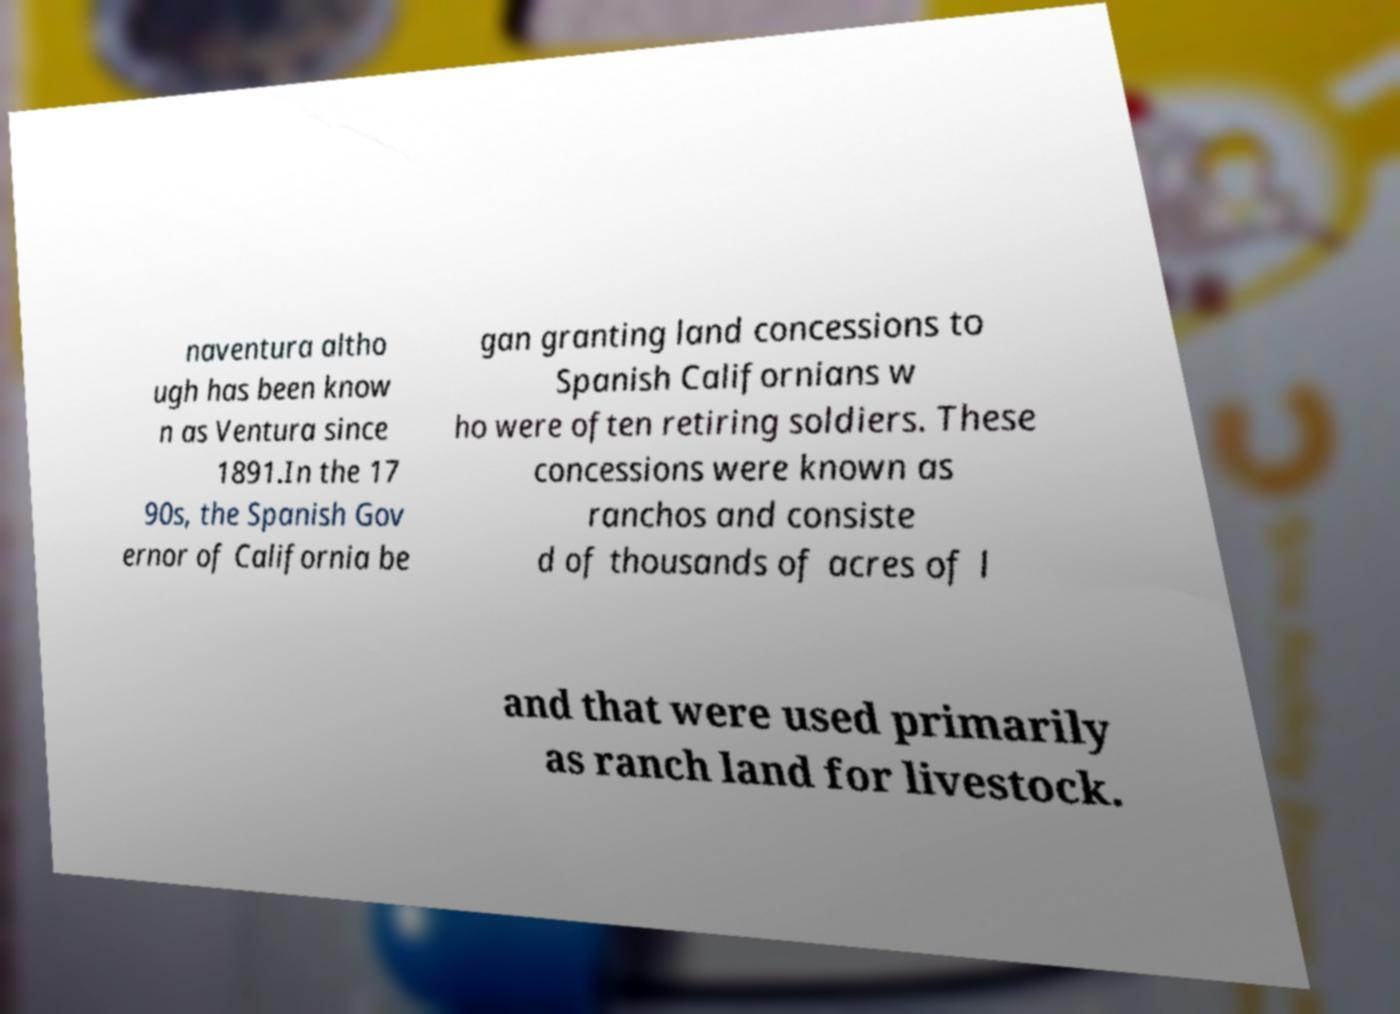Could you extract and type out the text from this image? naventura altho ugh has been know n as Ventura since 1891.In the 17 90s, the Spanish Gov ernor of California be gan granting land concessions to Spanish Californians w ho were often retiring soldiers. These concessions were known as ranchos and consiste d of thousands of acres of l and that were used primarily as ranch land for livestock. 